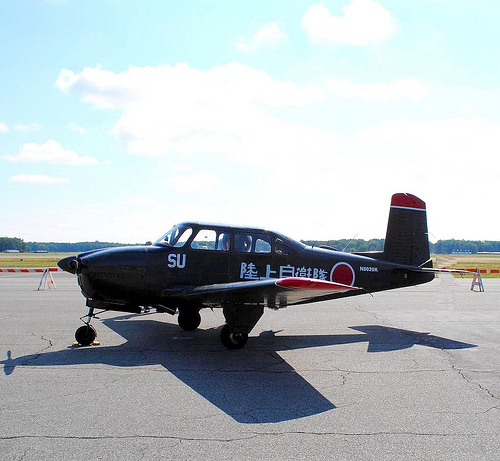Please provide the bounding box coordinate of the region this sentence describes: white clouds in blue sky. The bounding box coordinates for the region describing 'white clouds in blue sky' are [0.15, 0.19, 0.33, 0.32], capturing a beautiful part of the sky visible from the plane. 